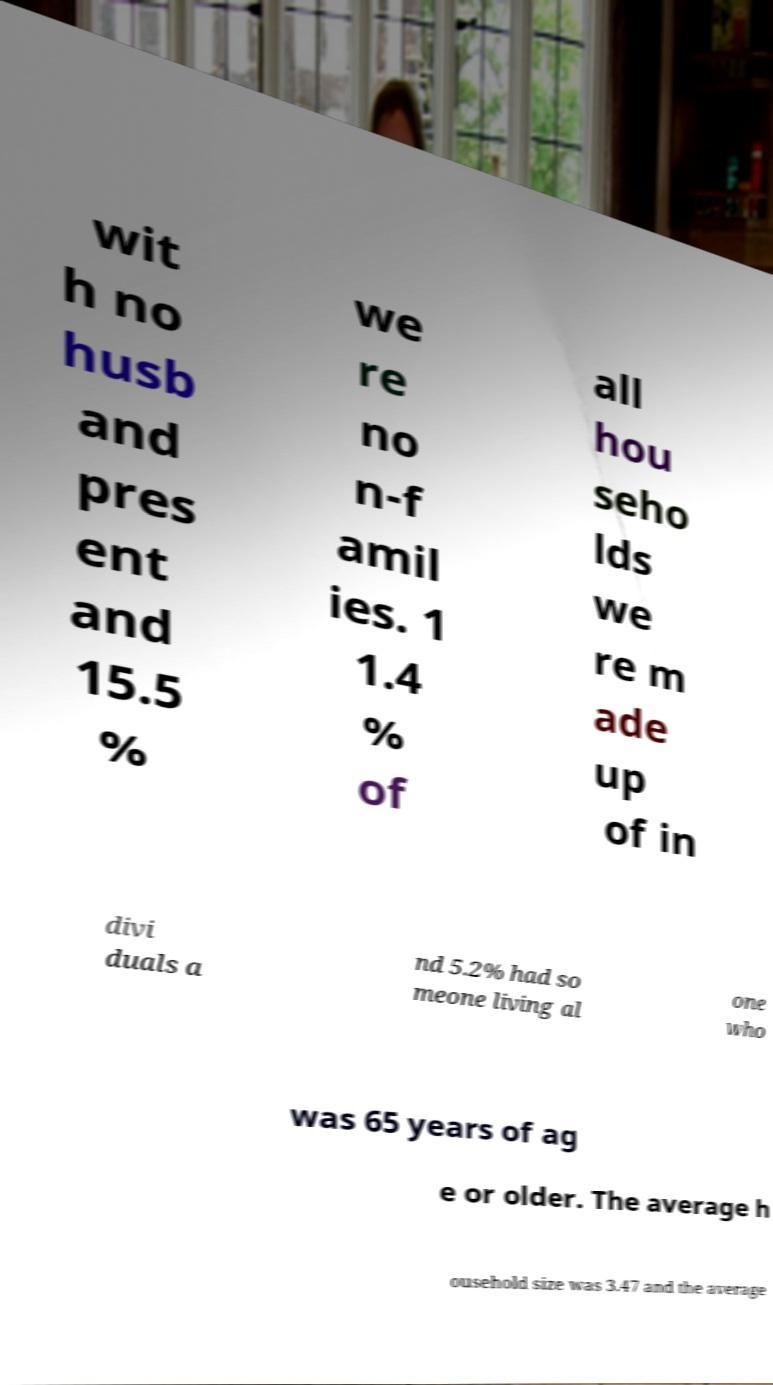There's text embedded in this image that I need extracted. Can you transcribe it verbatim? wit h no husb and pres ent and 15.5 % we re no n-f amil ies. 1 1.4 % of all hou seho lds we re m ade up of in divi duals a nd 5.2% had so meone living al one who was 65 years of ag e or older. The average h ousehold size was 3.47 and the average 